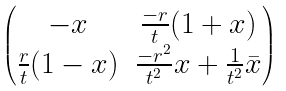<formula> <loc_0><loc_0><loc_500><loc_500>\begin{pmatrix} - x & \frac { - r } { t } ( 1 + x ) \\ \frac { r } { t } ( 1 - x ) & \frac { - r ^ { 2 } } { t ^ { 2 } } x + \frac { 1 } { t ^ { 2 } } \bar { x } \\ \end{pmatrix}</formula> 